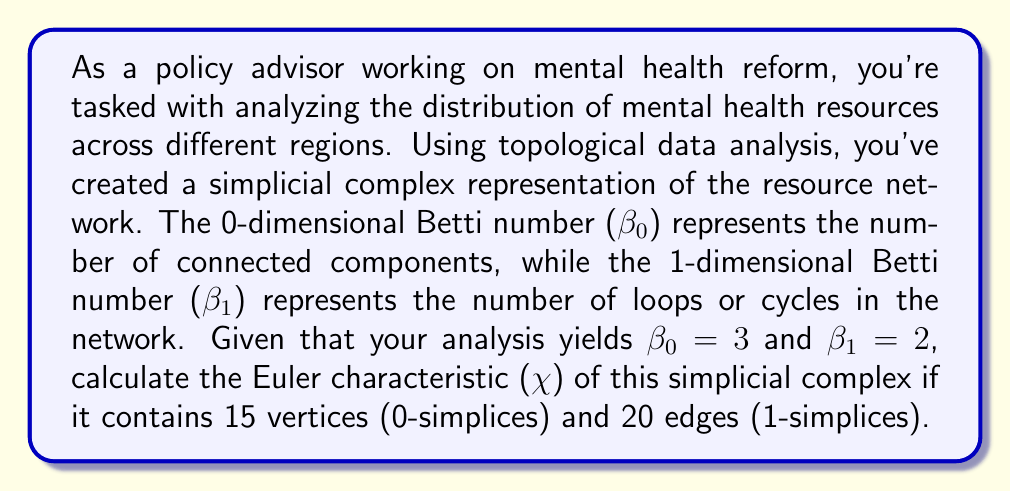Could you help me with this problem? To solve this problem, we need to use the Euler characteristic formula for simplicial complexes and the given information about Betti numbers. Let's approach this step-by-step:

1) The Euler characteristic ($\chi$) of a simplicial complex is defined as the alternating sum of the number of simplices in each dimension:

   $$\chi = n_0 - n_1 + n_2 - n_3 + \cdots$$

   where $n_i$ is the number of $i$-dimensional simplices.

2) In our case, we're given:
   - $n_0 = 15$ (15 vertices or 0-simplices)
   - $n_1 = 20$ (20 edges or 1-simplices)

3) We're not given any information about higher-dimensional simplices, so we assume $n_2 = n_3 = \cdots = 0$.

4) The Euler characteristic is also related to Betti numbers by the formula:

   $$\chi = \beta_0 - \beta_1 + \beta_2 - \beta_3 + \cdots$$

5) We're given:
   - $\beta_0 = 3$
   - $\beta_1 = 2$
   - We assume $\beta_2 = \beta_3 = \cdots = 0$ (since we don't have higher-dimensional simplices)

6) Now, let's calculate $\chi$ using the first formula:

   $$\chi = n_0 - n_1 = 15 - 20 = -5$$

7) We can verify this using the second formula:

   $$\chi = \beta_0 - \beta_1 = 3 - 2 = 1$$

8) The fact that these two calculations don't match indicates that our simplicial complex contains 2-simplices (triangles) that we need to account for.

9) Let $n_2$ be the number of 2-simplices. Then:

   $$15 - 20 + n_2 = 3 - 2$$
   $$n_2 = (3 - 2) - (15 - 20) = 1 - (-5) = 6$$

10) Therefore, the simplicial complex must contain 6 2-simplices (triangles).

11) The correct Euler characteristic is indeed:

    $$\chi = 15 - 20 + 6 = 1$$

This analysis reveals that the mental health resource network has 3 disconnected components, 2 cycles, and 6 triangular relationships, providing insights into the complexity and connectivity of the resource distribution.
Answer: The Euler characteristic ($\chi$) of the simplicial complex is 1, and the complex contains 6 2-simplices (triangles) in addition to the given 15 vertices and 20 edges. 